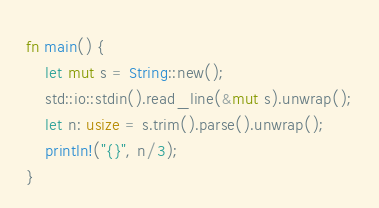Convert code to text. <code><loc_0><loc_0><loc_500><loc_500><_Rust_>fn main() {
    let mut s = String::new();
    std::io::stdin().read_line(&mut s).unwrap();
    let n: usize = s.trim().parse().unwrap();
    println!("{}", n/3);
}


</code> 